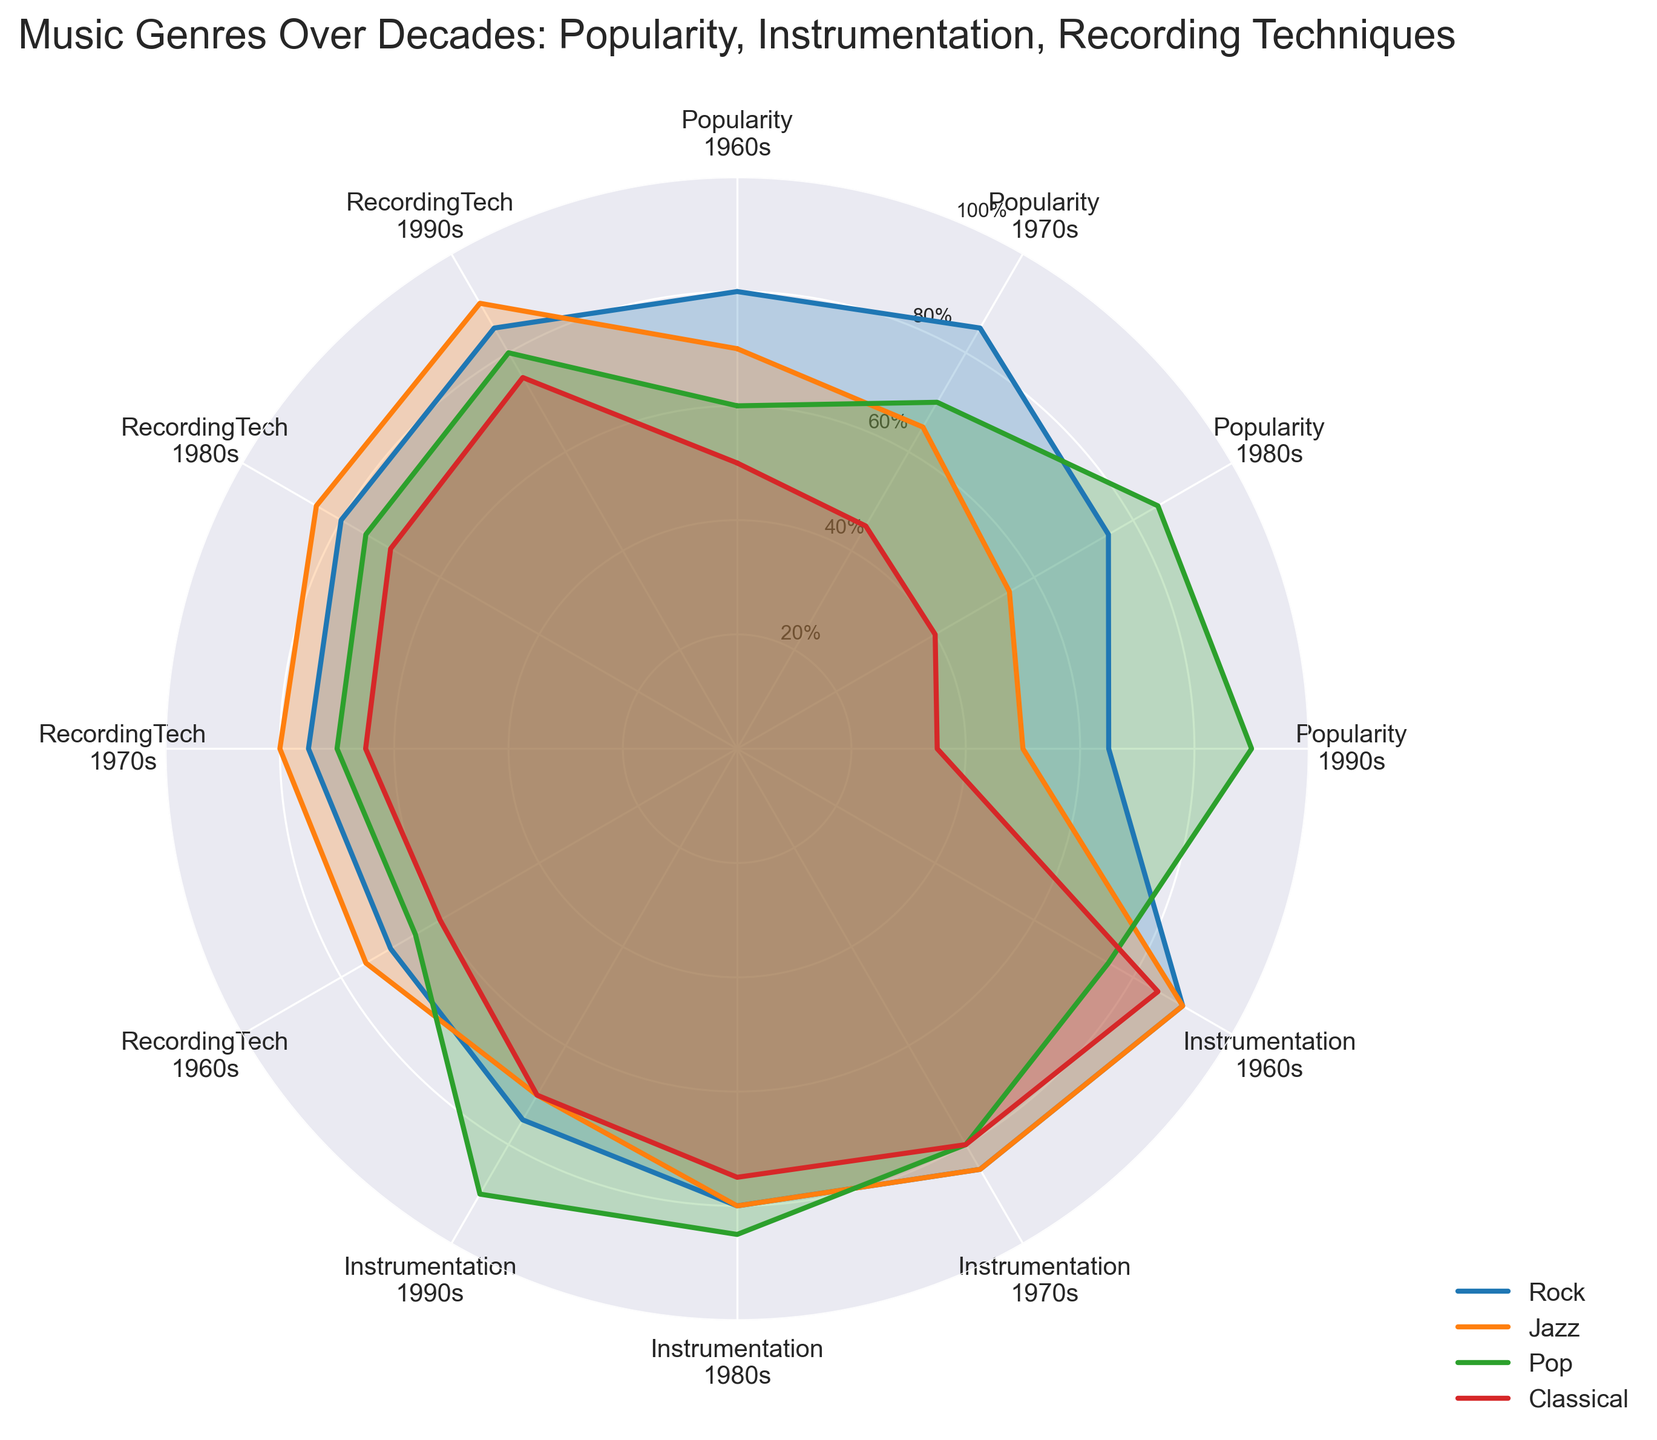what's the title of the plot? The title is displayed prominently at the top of the plot.
Answer: Music Genres Over Decades: Popularity, Instrumentation, Recording Techniques which genre had the highest popularity in the 1970s? By looking at the chart and identifying the highest point in the Popularity segment for the 1970s, we can see that Rock has a value of 85, which is higher than Jazz, Pop, and Classical.
Answer: Rock which genre's instrumentation declined the most from the 1960s to the 1990s? We need to compare the Instrumentation values for each genre from the 1960s to the 1990s. Rock goes from 90 to 75, a decline of 15; Jazz from 90 to 70, a decline of 20; Pop from 75 to 90, an increase; Classical from 85 to 70, a decline of 15. Jazz shows the largest decline.
Answer: Jazz among the genres, which shows the most consistent recording techniques improvement over the decades? Analyzing each genre's trajectory on the RecordingTech segment, we can see that Pop demonstrates a consistent increase from 65 in the 1960s to 80 in the 1990s without any decline.
Answer: Pop how does the popularity of Pop in the 1990s compare with Rock in the 1960s? From the chart, Pop’s popularity in the 1990s is 90, while Rock's popularity in the 1960s is 80. Pop in the 1990s is greater than Rock in the 1960s.
Answer: Pop in the 1990s is higher what is the average popularity across the decades for Jazz? We find the popularity values for Jazz across the decades: 70 in the 1960s, 65 in the 1970s, 55 in the 1980s, and 50 in the 1990s. The average is calculated by (70 + 65 + 55 + 50) / 4 = 60.
Answer: 60 which genre had the least improvement in recording techniques from the 1960s to the 1990s? We need to compare the recording techniques values for each genre from the 1960s to the 1990s. Rock goes from 70 to 85 (improvement of 15), Jazz from 75 to 90 (improvement of 15), Pop from 65 to 80 (improvement of 15), and Classical from 60 to 75 (improvement of 15). All genres have the same improvement, so none had the least improvement.
Answer: None compare the instrumentation values of Pop and Classical in the 1980s. which is higher? We look at the Instrumentation segment for the 1980s. Pop has a value of 85, and Classical has a value of 75. Pop's value is higher.
Answer: Pop which genre has the sharpest decline in popularity over the whole duration? A sharp decline would be indicated by a significant reduction in values over the decades. Jazz goes from 70 to 50, a decline of 20, which is the steepest decline among all genres.
Answer: Jazz 